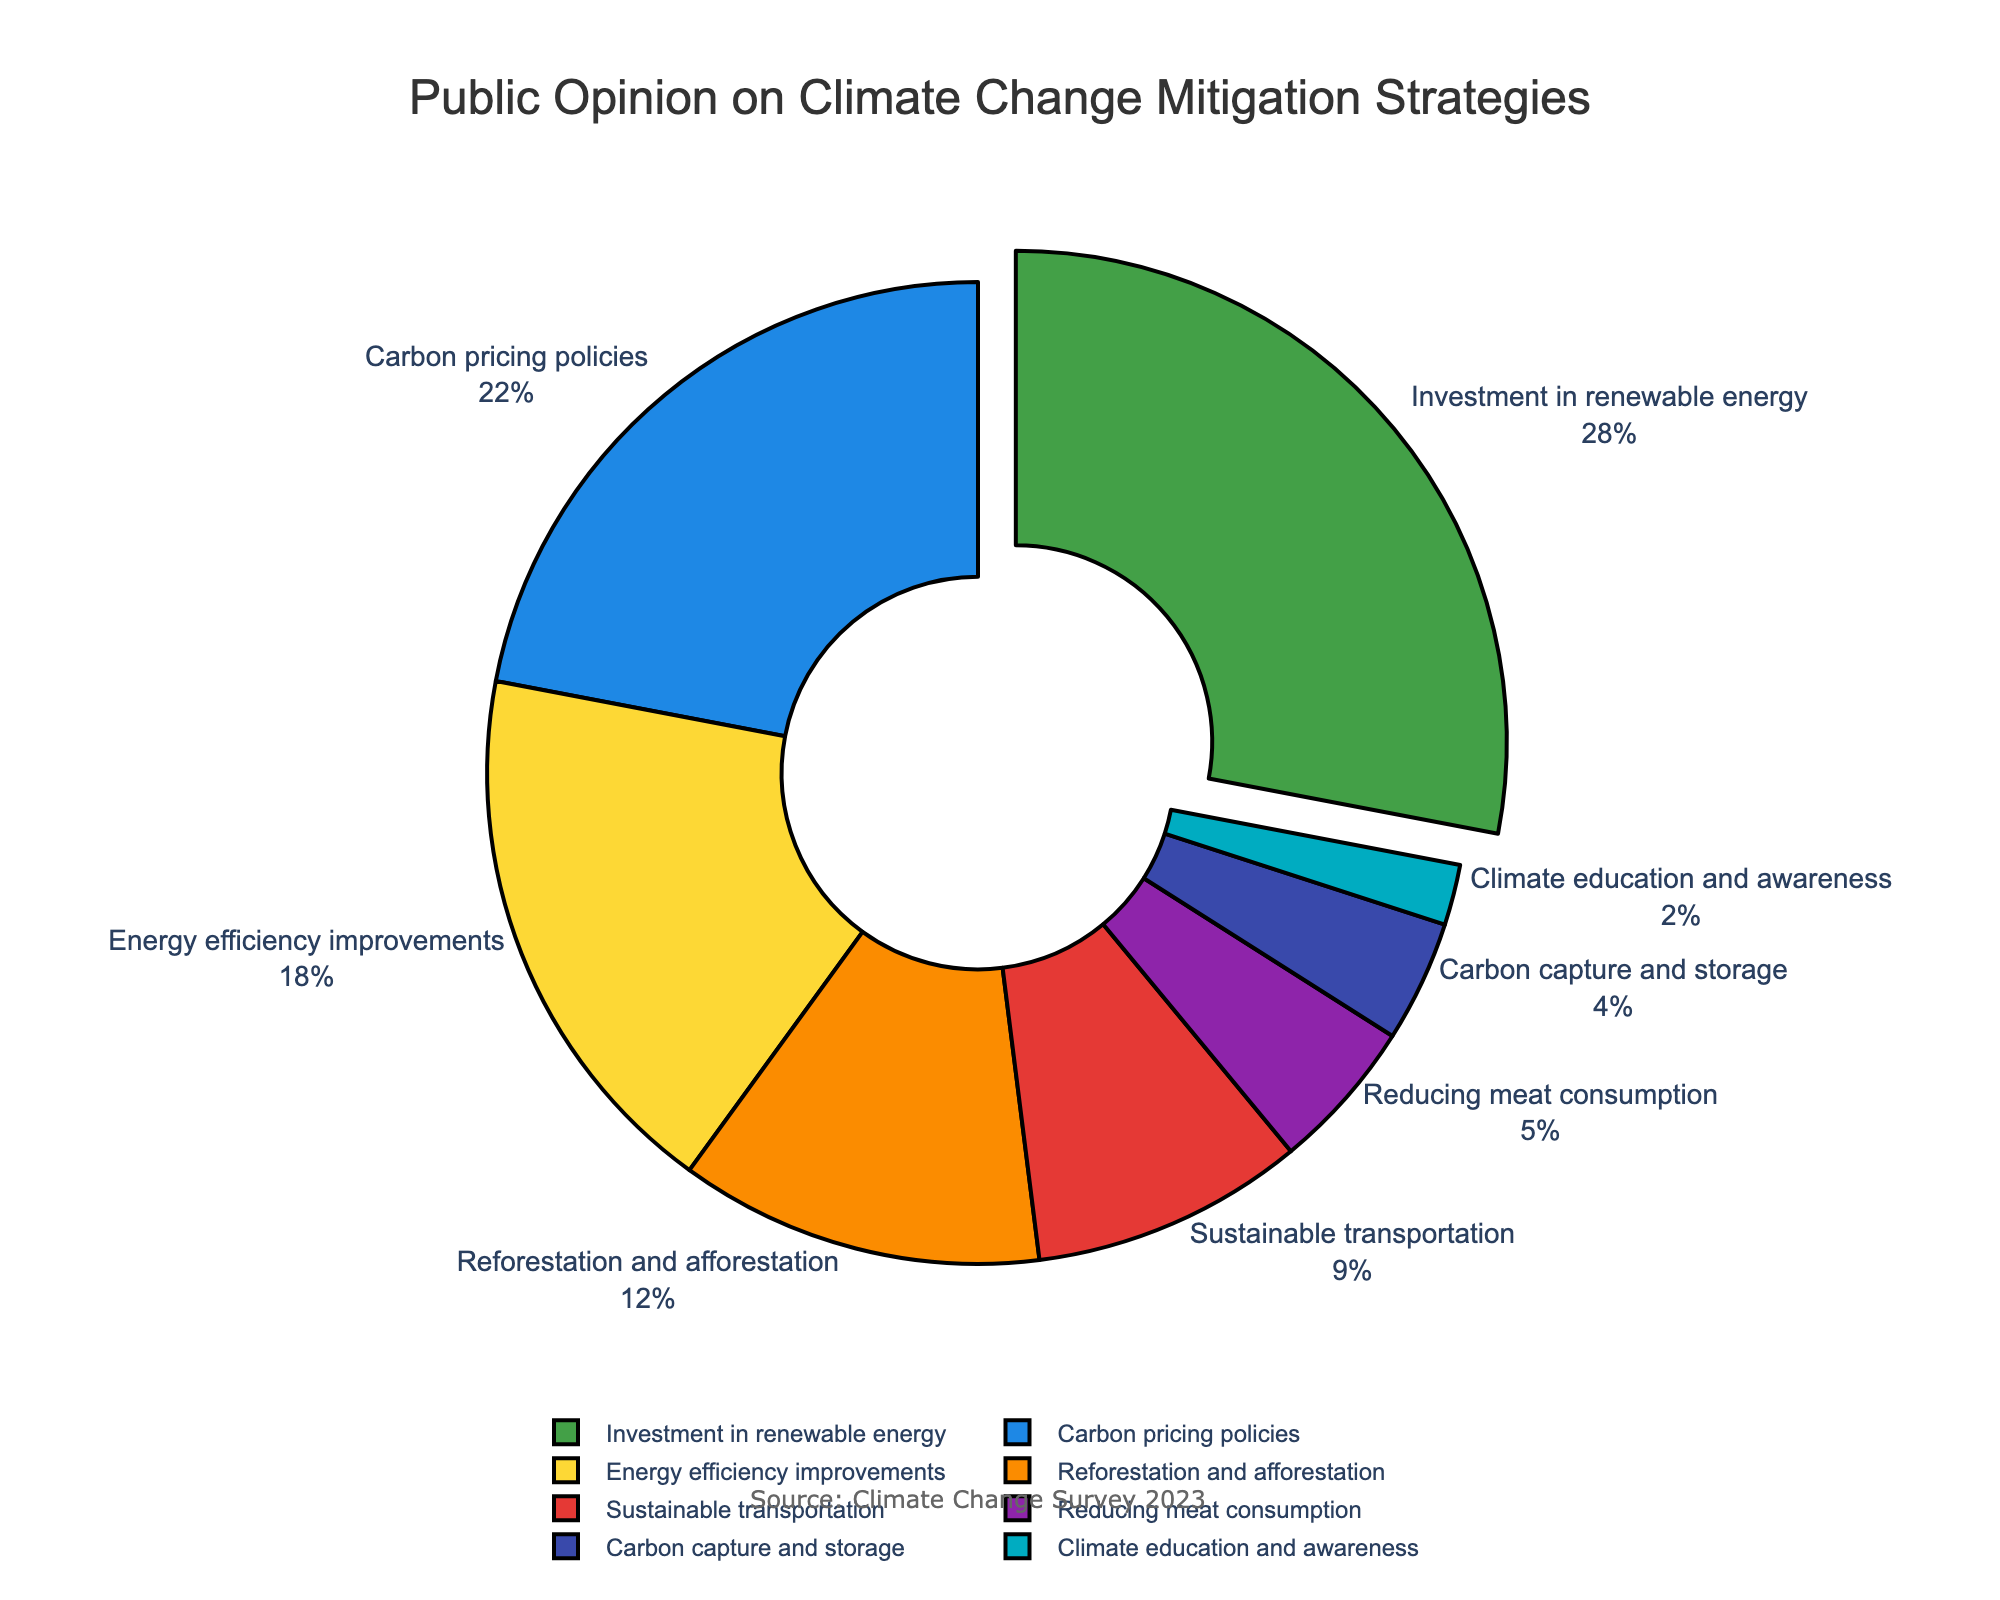What strategy has the highest level of public support? The pie chart shows the percentage of public opinion on several climate change mitigation strategies. The segment with the highest percentage represents the strategy with the most support. By examining the chart, "Investment in renewable energy" has the largest segment.
Answer: Investment in renewable energy Which strategy has the least public support, and what percentage of people support it? The smallest segment on the pie chart represents the strategy with the least public support. "Climate education and awareness" is the smallest segment with a 2% support rate.
Answer: Climate education and awareness, 2% How much more support does "Energy efficiency improvements" have compared to "Sustainable transportation"? Subtract the percentage of "Sustainable transportation" from "Energy efficiency improvements" to determine the difference. Look at the values (18% for Energy efficiency improvements and 9% for Sustainable transportation): 18% - 9% = 9%.
Answer: 9% What strategies have a combined support percentage greater than 30%? Combine the percentages of various strategies and find those whose sum is greater than 30%. "Investment in renewable energy" (28%) and "Carbon pricing policies" (22%) independently have more than 30%. However, "Energy efficiency improvements" (18%) and "Reforestation and afforestation" (12%) together are also above 30%.
Answer: Investment in renewable energy, Carbon pricing policies, Energy efficiency improvements + Reforestation and afforestation Which strategy is supported by more people: "Reforestation and afforestation" or "Energy efficiency improvements"? Compare the percentages directly from the chart. "Energy efficiency improvements" (18%) has a larger segment than "Reforestation and afforestation" (12%).
Answer: Energy efficiency improvements How does the support for "Reducing meat consumption" compare to "Carbon capture and storage"? Compare the two segments to determine which is larger and by how much. "Reducing meat consumption" is at 5% and "Carbon capture and storage" is at 4%. The difference is 5% - 4% = 1%.
Answer: 1% What is the total percentage of support for strategies involving carbon directly ("Carbon pricing policies" and "Carbon capture and storage")? Add the percentages of "Carbon pricing policies" (22%) and "Carbon capture and storage" (4%). The sum is 22% + 4% = 26%.
Answer: 26% How many strategies have less than 10% public support? Identify segments on the chart with percentages below 10%. Then, count these segments. The strategies are "Sustainable transportation" (9%), "Reducing meat consumption" (5%), "Carbon capture and storage" (4%), and "Climate education and awareness" (2%). There are 4 such strategies.
Answer: 4 